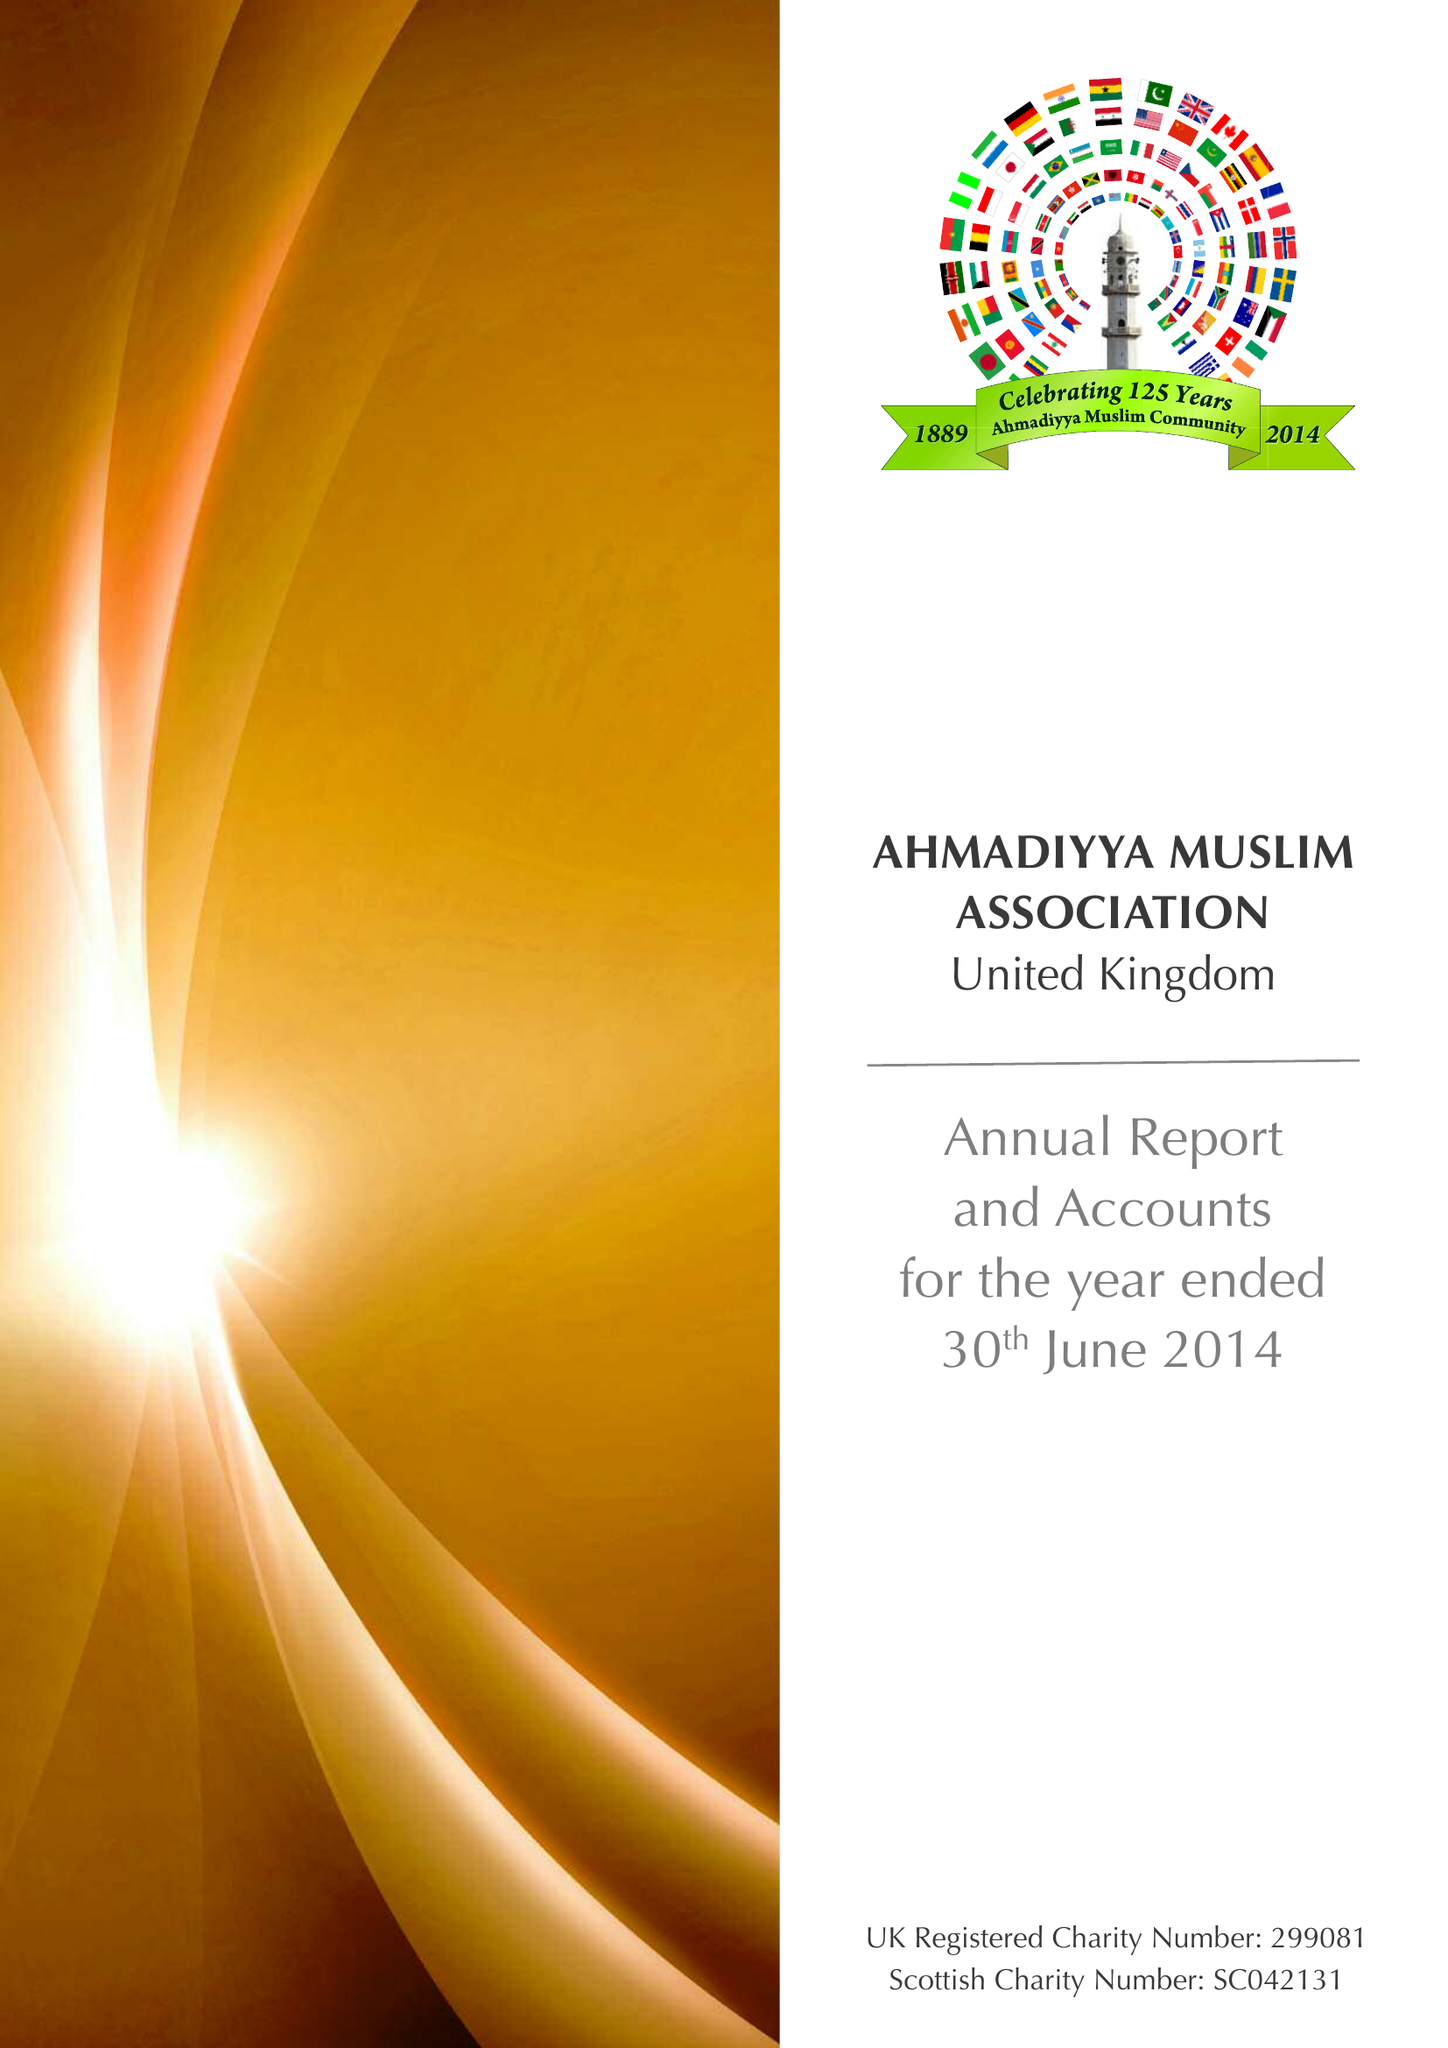What is the value for the charity_name?
Answer the question using a single word or phrase. Ahmadiyya Muslim Association United Kingdom 